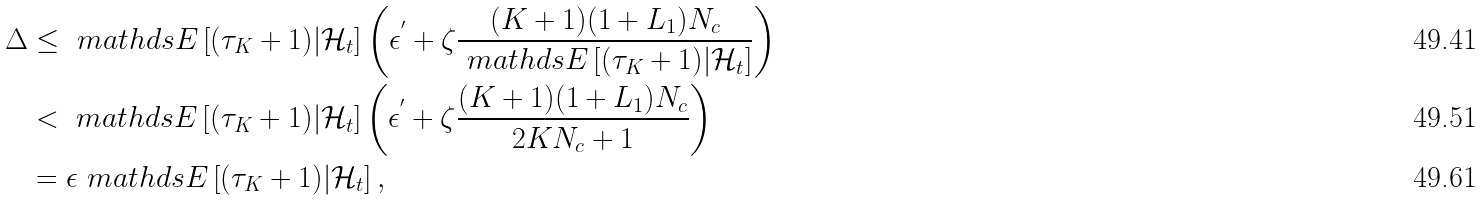<formula> <loc_0><loc_0><loc_500><loc_500>\Delta & \leq \ m a t h d s { E } \left [ ( \tau _ { K } + 1 ) | \mathcal { H } _ { t } \right ] \left ( \epsilon ^ { ^ { \prime } } + \zeta \frac { ( K + 1 ) ( 1 + L _ { 1 } ) N _ { c } } { \ m a t h d s { E } \left [ ( \tau _ { K } + 1 ) | \mathcal { H } _ { t } \right ] } \right ) \\ & < \ m a t h d s { E } \left [ ( \tau _ { K } + 1 ) | \mathcal { H } _ { t } \right ] \left ( \epsilon ^ { ^ { \prime } } + \zeta \frac { ( K + 1 ) ( 1 + L _ { 1 } ) N _ { c } } { 2 K N _ { c } + 1 } \right ) \\ & = \epsilon \ m a t h d s { E } \left [ ( \tau _ { K } + 1 ) | \mathcal { H } _ { t } \right ] ,</formula> 